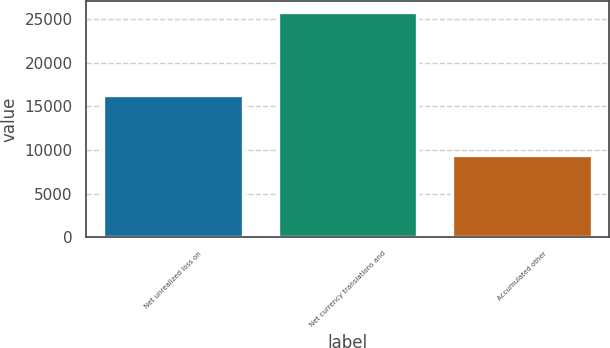Convert chart. <chart><loc_0><loc_0><loc_500><loc_500><bar_chart><fcel>Net unrealized loss on<fcel>Net currency translations and<fcel>Accumulated other<nl><fcel>16318<fcel>25765<fcel>9447<nl></chart> 